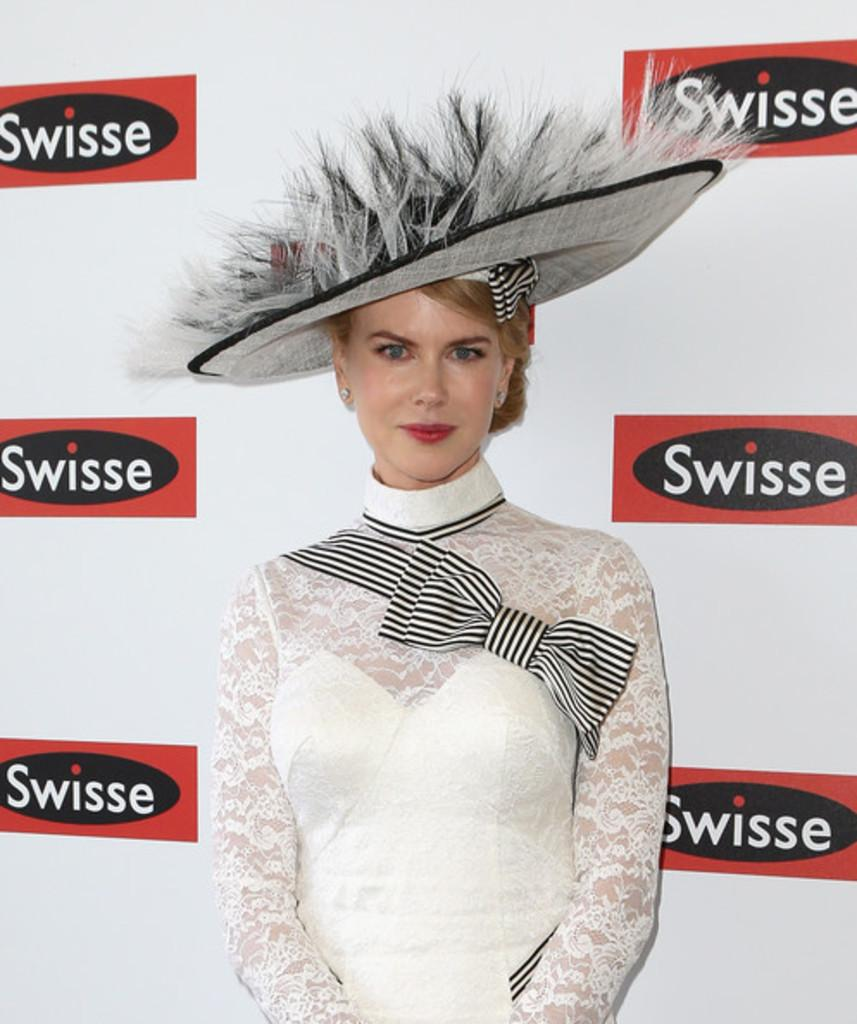Who is present in the image? There is a woman in the image. What is the woman doing in the image? The woman is standing in the image. What is the woman wearing on her head? The woman is wearing a hat in the image. What is the woman's facial expression in the image? The woman is smiling in the image. What can be seen in the background of the image? There is a banner visible in the background of the image. How many horses are present in the image? There are no horses present in the image. What type of property is the woman holding in her finger? The woman is not holding any property in her finger, as there is no property visible in the image. 